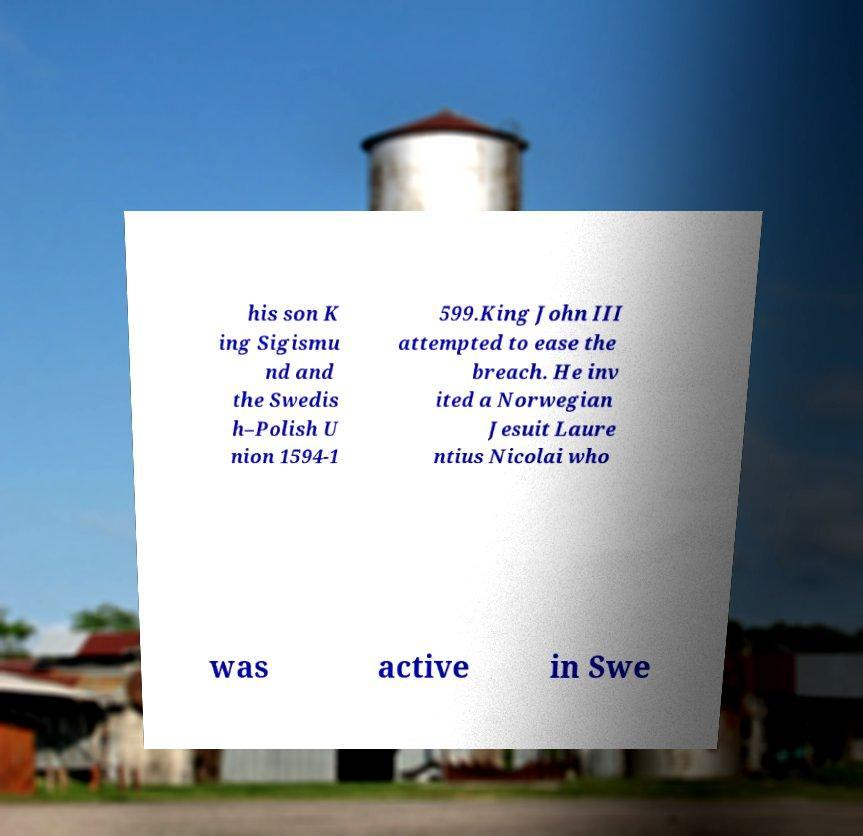I need the written content from this picture converted into text. Can you do that? his son K ing Sigismu nd and the Swedis h–Polish U nion 1594-1 599.King John III attempted to ease the breach. He inv ited a Norwegian Jesuit Laure ntius Nicolai who was active in Swe 